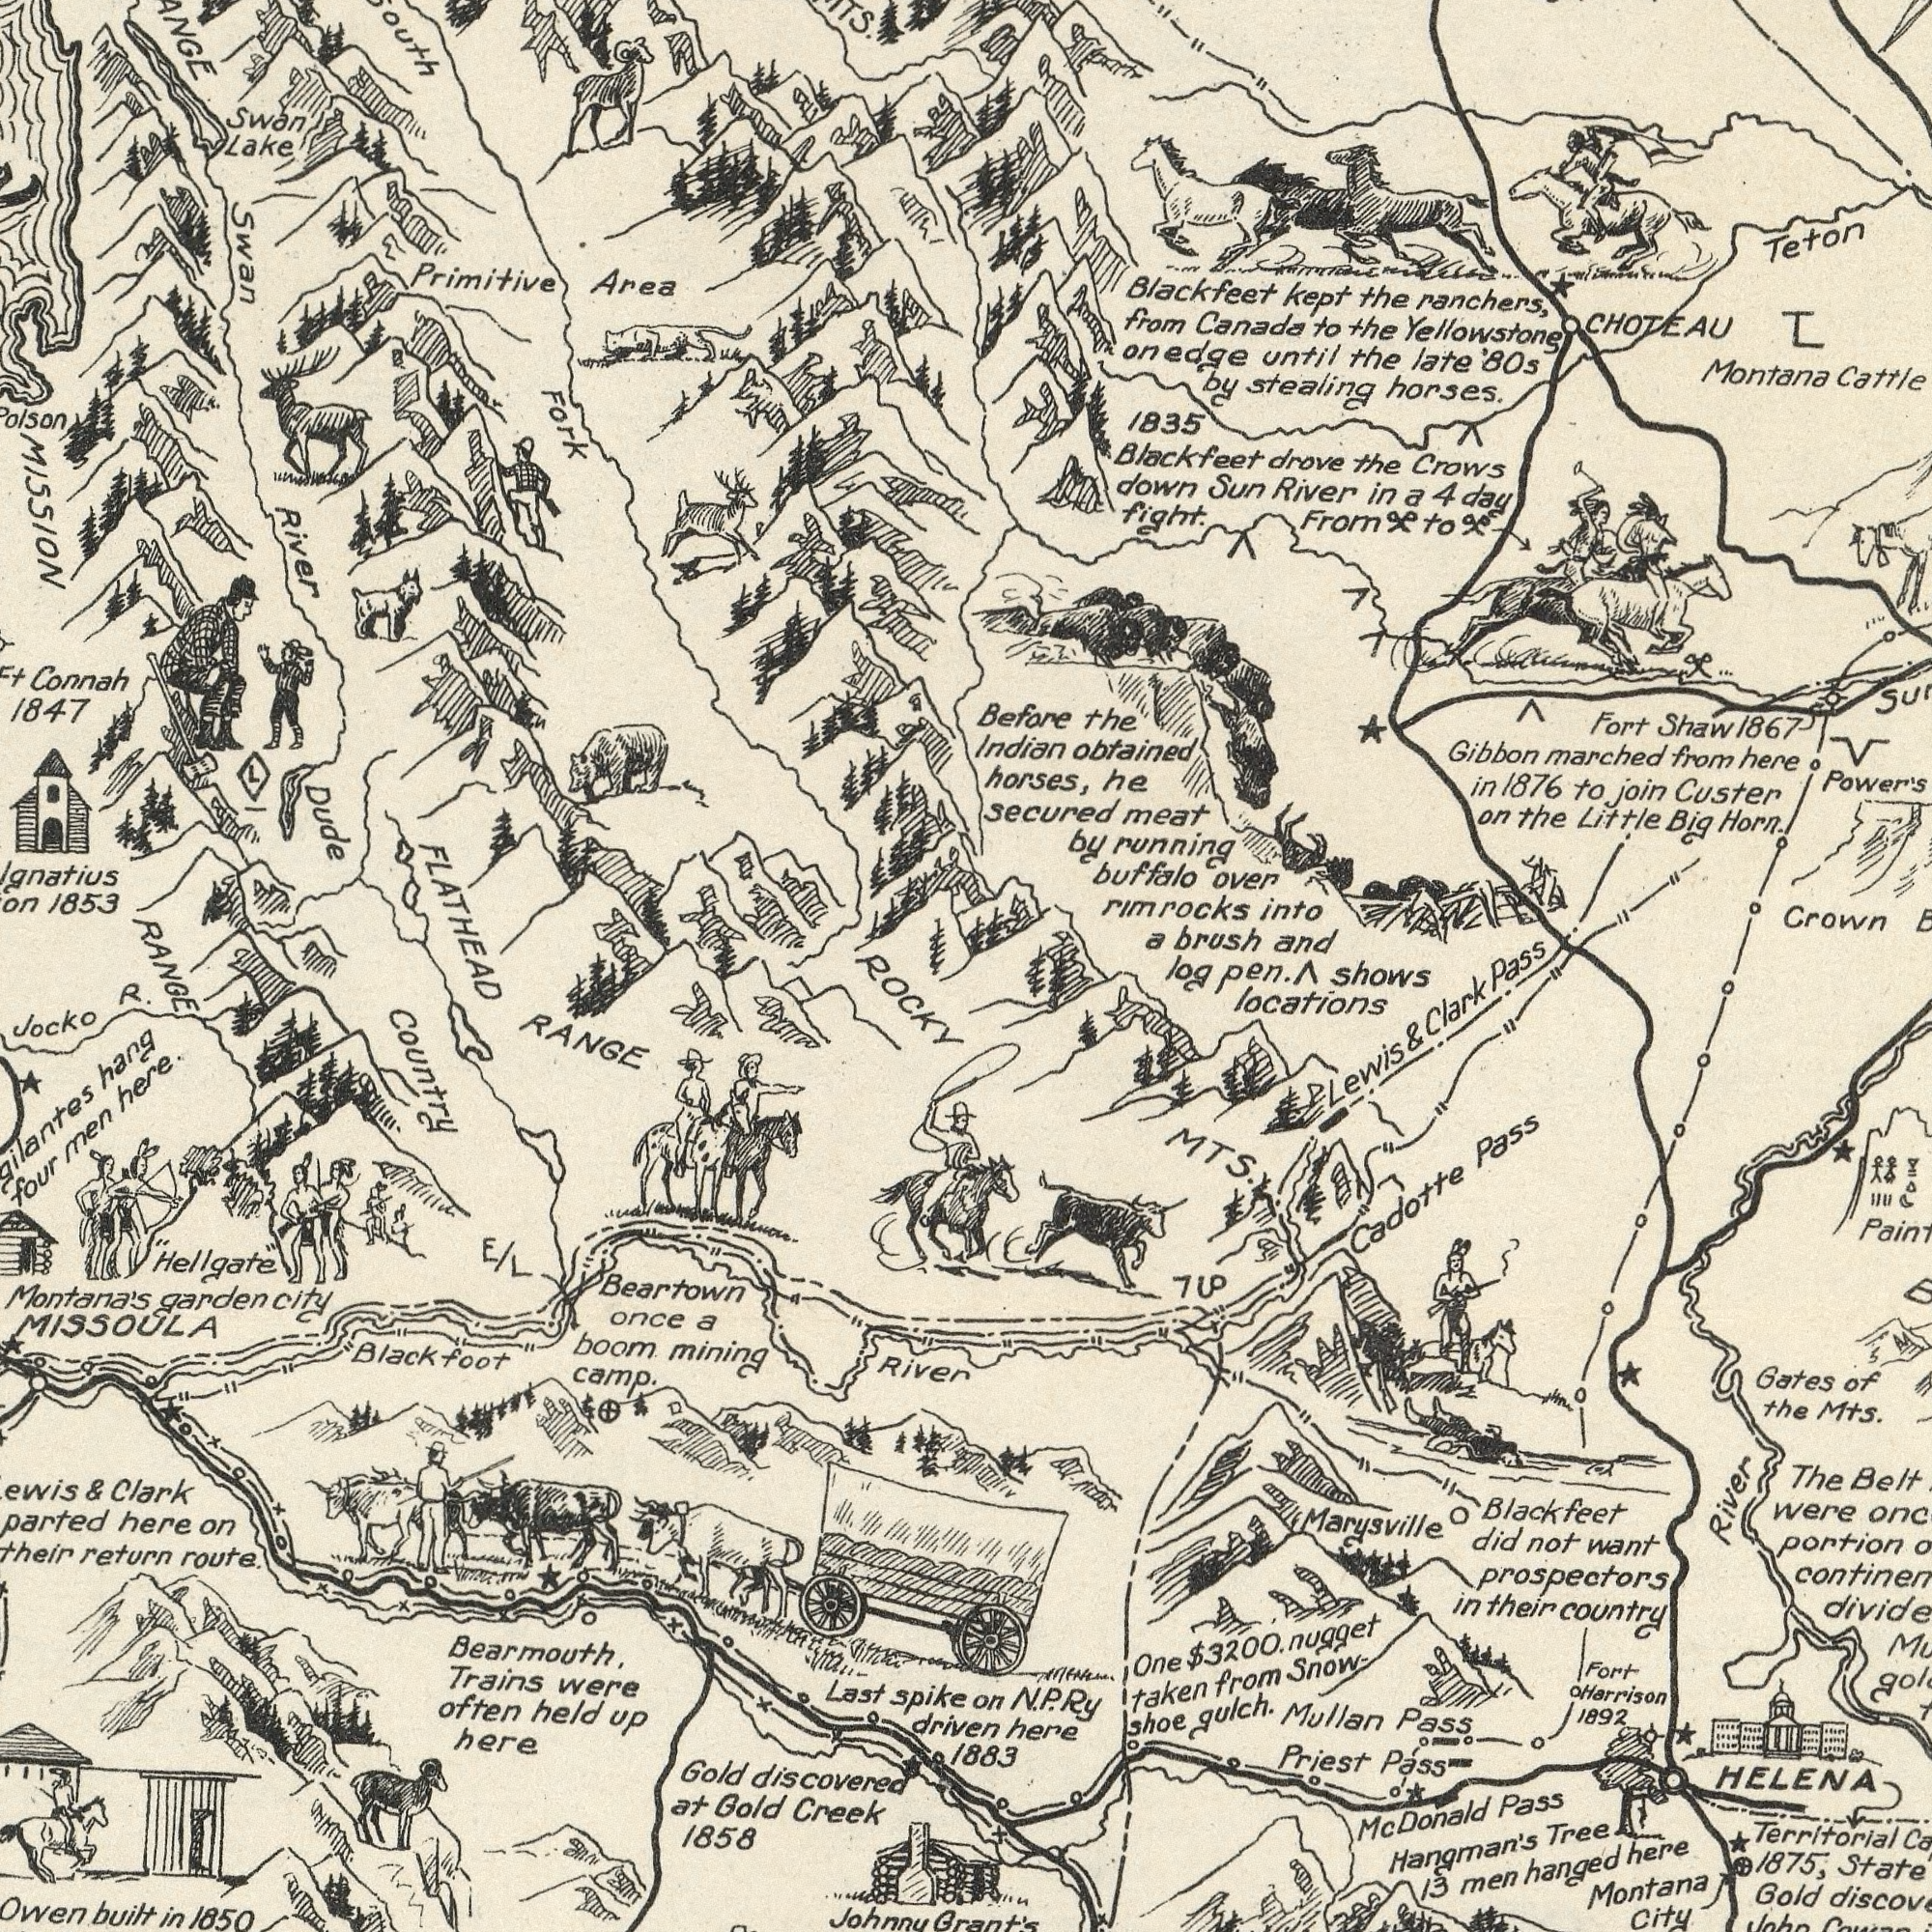What text appears in the top-right area of the image? rim River ranchers, Montana horses. stealing brush Before Blackfeet Teton Custer obtained Little Crows running Gibbon 1835 buffalo into Indian and kept Cattle Crown from Canada he the marched Sun the the fight. ‘80s over Blackfeet in Big drove the horses, until late down to by on the in meat join Fort Yellowstone 1876 Horn. a a secured to 4 the 1867 Shaw by day from CHOTEAU to From on pass here locations Shows Clark pen. edge rocks log What text appears in the bottom-right area of the image? Grant's HELENA Marysville Blackfeet Gates Priest Pass Territorial Cadotte Mts. portion Tree Montana Belt were here Snow_ Mullan Pass Pass 1883 City 1892 Gold want taken River MTS. 1875, The gulch. from not in of Harrison prospectors Lewis Pass N.P.Ry or did men One & $3200. hanged 13 Mc Fort their here Country nugget Shoe Hangman's Donald the 7U 5 M What text is visible in the lower-left corner? Montana's Creek Beartown Jocko 1858 MISSOULA River "Hellgate" Clark camp. here 1850 Owen here. Gold spike were hang boom Last Gold route. once driven often here built Country RANGE Black at & Trains return Johnnu mining on foot discovered held in a Bearmouth, four garden E/L city up men What text is visible in the upper-left corner? FLATHEAD Area 1847 Dude Fork 1853 Lake Swan MISSION Connah Primitive Swan River RANGE R. ROCKY L 